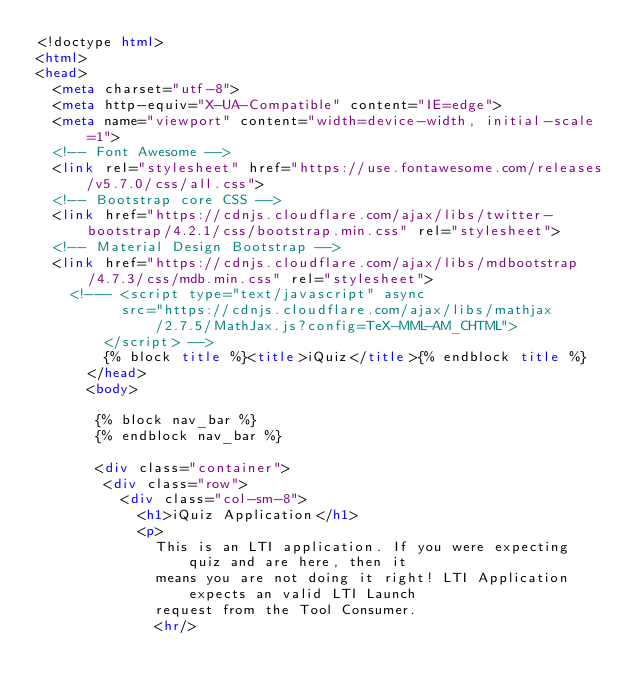<code> <loc_0><loc_0><loc_500><loc_500><_HTML_><!doctype html>
<html>
<head>
  <meta charset="utf-8">
  <meta http-equiv="X-UA-Compatible" content="IE=edge">
  <meta name="viewport" content="width=device-width, initial-scale=1">
  <!-- Font Awesome -->
  <link rel="stylesheet" href="https://use.fontawesome.com/releases/v5.7.0/css/all.css">
  <!-- Bootstrap core CSS -->
  <link href="https://cdnjs.cloudflare.com/ajax/libs/twitter-bootstrap/4.2.1/css/bootstrap.min.css" rel="stylesheet">
  <!-- Material Design Bootstrap -->
  <link href="https://cdnjs.cloudflare.com/ajax/libs/mdbootstrap/4.7.3/css/mdb.min.css" rel="stylesheet">
    <!--- <script type="text/javascript" async
          src="https://cdnjs.cloudflare.com/ajax/libs/mathjax/2.7.5/MathJax.js?config=TeX-MML-AM_CHTML">
        </script> -->
        {% block title %}<title>iQuiz</title>{% endblock title %}
      </head>
      <body>

       {% block nav_bar %}
       {% endblock nav_bar %}

       <div class="container">
        <div class="row">
          <div class="col-sm-8">
            <h1>iQuiz Application</h1>
            <p>
              This is an LTI application. If you were expecting quiz and are here, then it
              means you are not doing it right! LTI Application expects an valid LTI Launch
              request from the Tool Consumer.
              <hr/></code> 